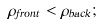<formula> <loc_0><loc_0><loc_500><loc_500>\rho _ { f r o n t } < \rho _ { b a c k } ;</formula> 